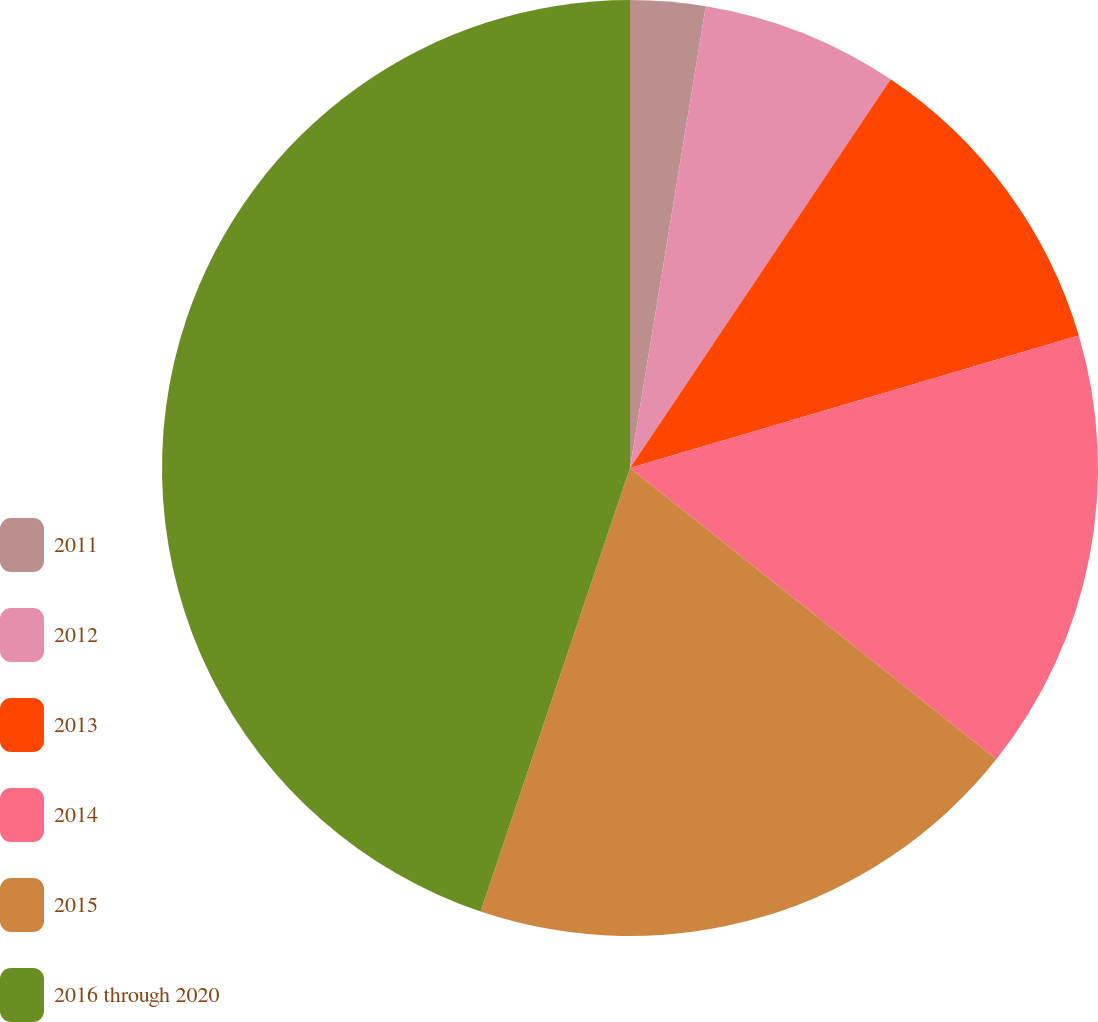<chart> <loc_0><loc_0><loc_500><loc_500><pie_chart><fcel>2011<fcel>2012<fcel>2013<fcel>2014<fcel>2015<fcel>2016 through 2020<nl><fcel>2.59%<fcel>6.81%<fcel>11.03%<fcel>15.26%<fcel>19.48%<fcel>44.83%<nl></chart> 